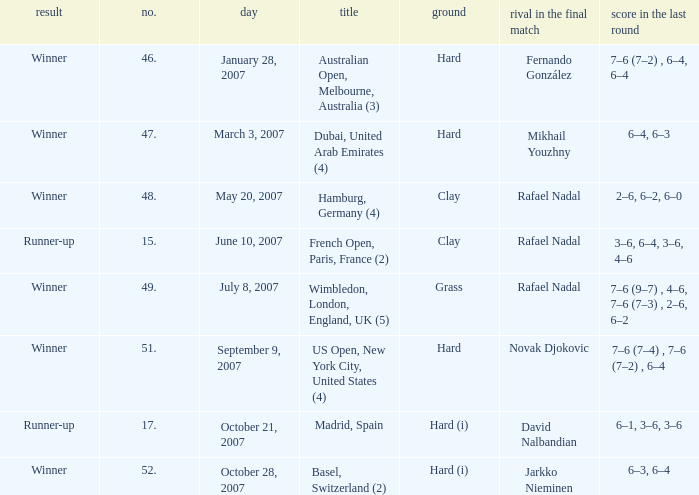The score in the final is 2–6, 6–2, 6–0, on what surface? Clay. 